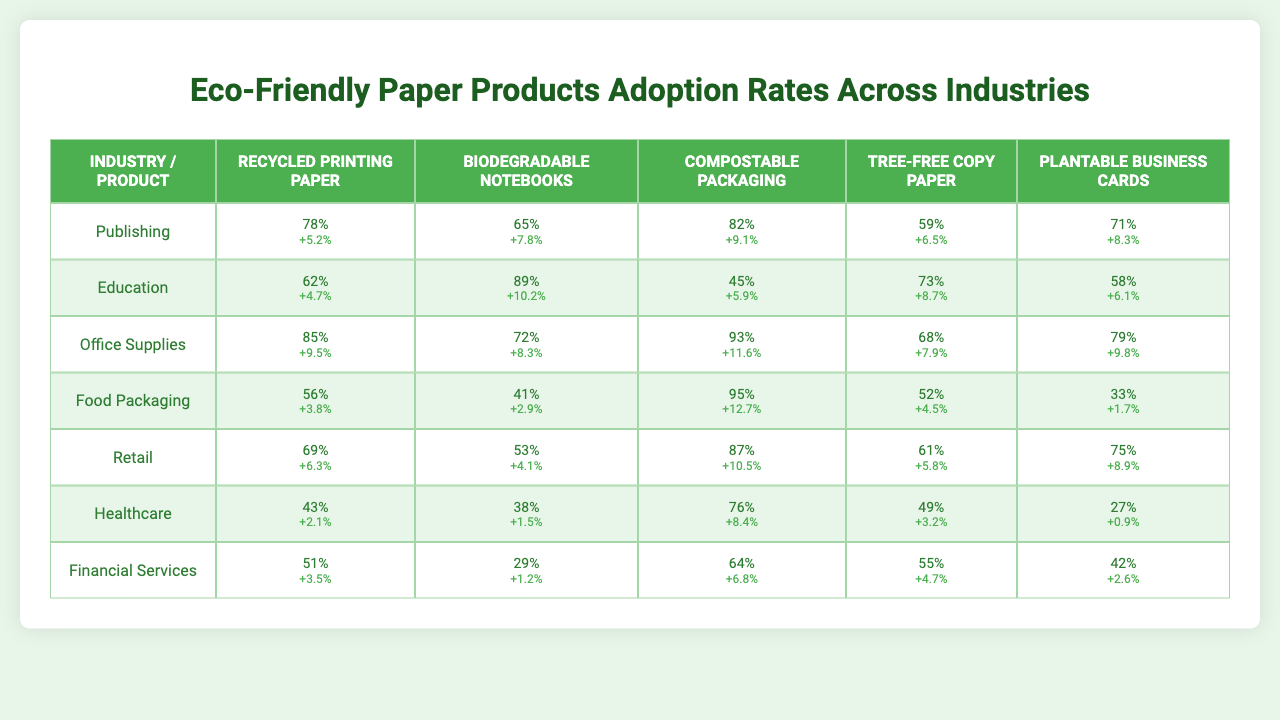What is the adoption rate of Recycled Printing Paper in the Office Supplies industry? The table shows that the adoption rate of Recycled Printing Paper in the Office Supplies industry is 85%.
Answer: 85% Which eco-friendly product has the highest adoption rate in the Food Packaging industry? According to the table, Compostable Packaging has the highest adoption rate at 95% in the Food Packaging industry.
Answer: Compostable Packaging What is the average adoption rate of Biodegradable Notebooks across all industries? The adoption rates for Biodegradable Notebooks are 65% (Publishing), 89% (Education), 72% (Office Supplies), 41% (Food Packaging), 53% (Retail), 38% (Healthcare), and 29% (Financial Services). Summing these gives us 65 + 89 + 72 + 41 + 53 + 38 + 29 = 387. Dividing by the number of industries, which is 7, results in an average of 387 / 7 ≈ 55.29%.
Answer: 55.29% Is the adoption rate of Plantable Business Cards in Healthcare higher than in Financial Services? In the table, the adoption rate of Plantable Business Cards is 27% for Healthcare and 42% for Financial Services. Therefore, 27% < 42%, so the adoption rate in Healthcare is not higher.
Answer: No What is the growth rate of the adoption of Tree-Free Copy Paper in the Retail industry, and how does it compare to its growth rate in the Publishing industry? The growth rate of Tree-Free Copy Paper in the Retail industry is 61% while in the Publishing industry it is 5.2%. Therefore, Retail has a significantly higher growth rate compared to Publishing.
Answer: Retail has a higher growth rate What is the total adoption rate of eco-friendly products across the Education industry, and how does it compare to the total adoption rate in the Healthcare industry? To find the total adoption rate for the Education industry, we sum the rates: 62% (Recycled Printing Paper) + 89% (Biodegradable Notebooks) + 45% (Compostable Packaging) + 73% (Tree-Free Copy Paper) + 58% (Plantable Business Cards) = 327%. For Healthcare, the rates are: 43% + 38% + 76% + 49% + 27% = 233%. Therefore, 327% > 233%, indicating that Education has a higher total adoption rate than Healthcare.
Answer: Education has a higher total adoption rate Which industry has the lowest adoption rate for any eco-friendly product, and what is that rate? The lowest adoption rates in the table can be seen in the Healthcare industry, where its lowest is 27% for Plantable Business Cards.
Answer: Healthcare, 27% 